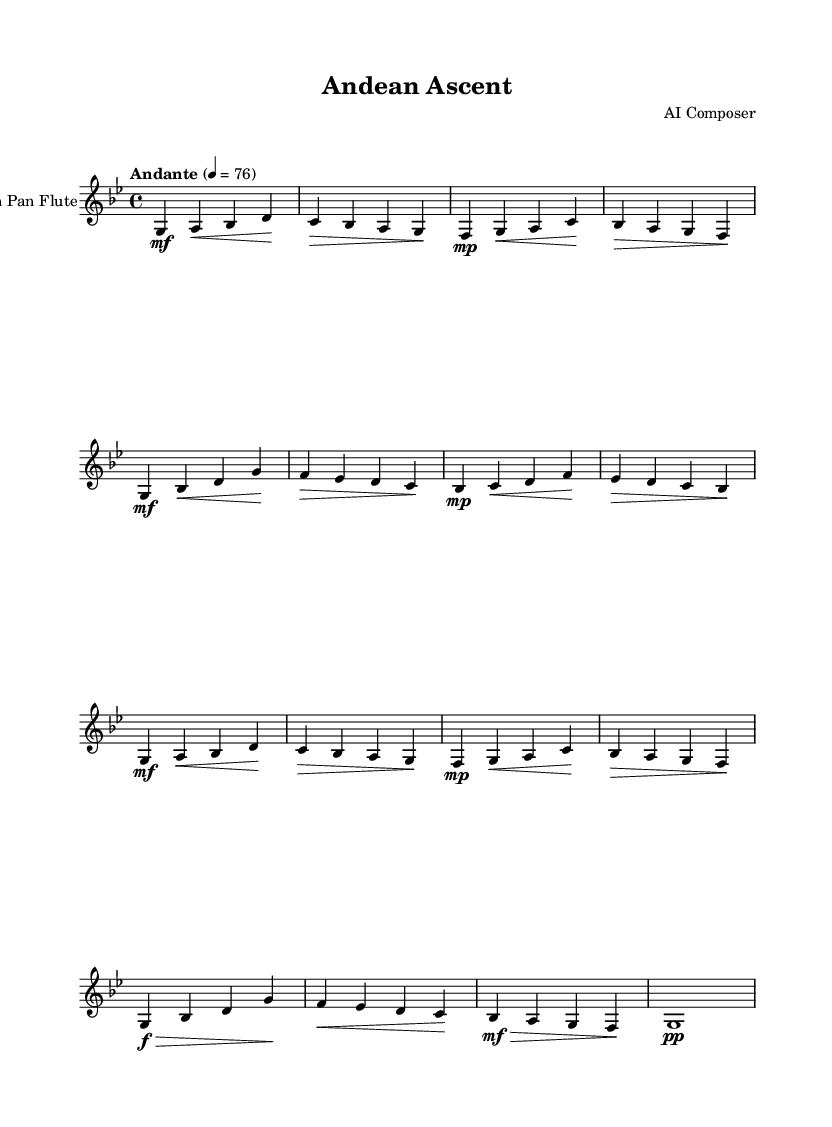What is the key signature of this music? The key signature shows that there are two flats, indicating that the key is G minor.
Answer: G minor What is the time signature of this music? The time signature is indicated by the notation seen at the beginning of the score; it is 4/4, which means there are four beats per measure.
Answer: 4/4 What is the tempo marking of the piece? The tempo marking written in the score specifies "Andante" with a metronome marking of 76, which describes the speed at which the piece should be played.
Answer: Andante 76 How many measures are there in this melody? By counting the number of vertical bar lines (which denote the end of measures) in the score, there are a total of ten measures present in this melody.
Answer: 10 Which instrument is this score written for? The instrument name is explicitly stated in the score as "Andean Pan Flute," which is the intended performer of this composition.
Answer: Andean Pan Flute Describe the dynamics indicated in the second measure. In the second measure, the dynamics show a mezzo-forte marking (mf) at the beginning, indicating a moderately loud volume for that section.
Answer: mezzo-forte What melodic contour is predominantly used in this piece? The melodic contour features a combination of ascending and descending pitches, particularly notable in the first phrase which begins with an upward motion.
Answer: Ascending and descending 